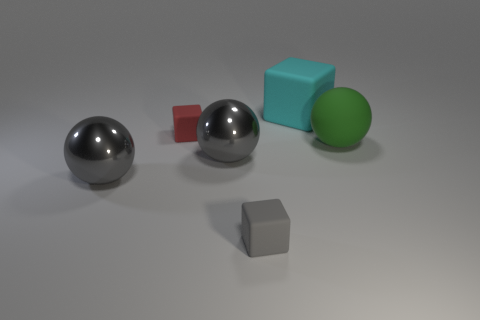There is a big sphere that is both to the right of the small red thing and to the left of the tiny gray thing; what material is it made of?
Offer a terse response. Metal. What shape is the cyan object that is the same size as the green matte thing?
Your response must be concise. Cube. There is a sphere on the right side of the small rubber cube that is in front of the big matte thing that is in front of the big cyan matte object; what is its color?
Keep it short and to the point. Green. How many things are tiny cubes that are left of the tiny gray rubber thing or big green spheres?
Ensure brevity in your answer.  2. What material is the cyan block that is the same size as the green thing?
Give a very brief answer. Rubber. The tiny object in front of the green thing behind the block that is in front of the tiny red matte thing is made of what material?
Offer a terse response. Rubber. What is the color of the big cube?
Keep it short and to the point. Cyan. How many large objects are either cyan cubes or gray metallic balls?
Keep it short and to the point. 3. Do the large thing that is behind the small red rubber block and the big ball to the right of the big cyan rubber cube have the same material?
Offer a very short reply. Yes. Is there a green ball?
Your response must be concise. Yes. 